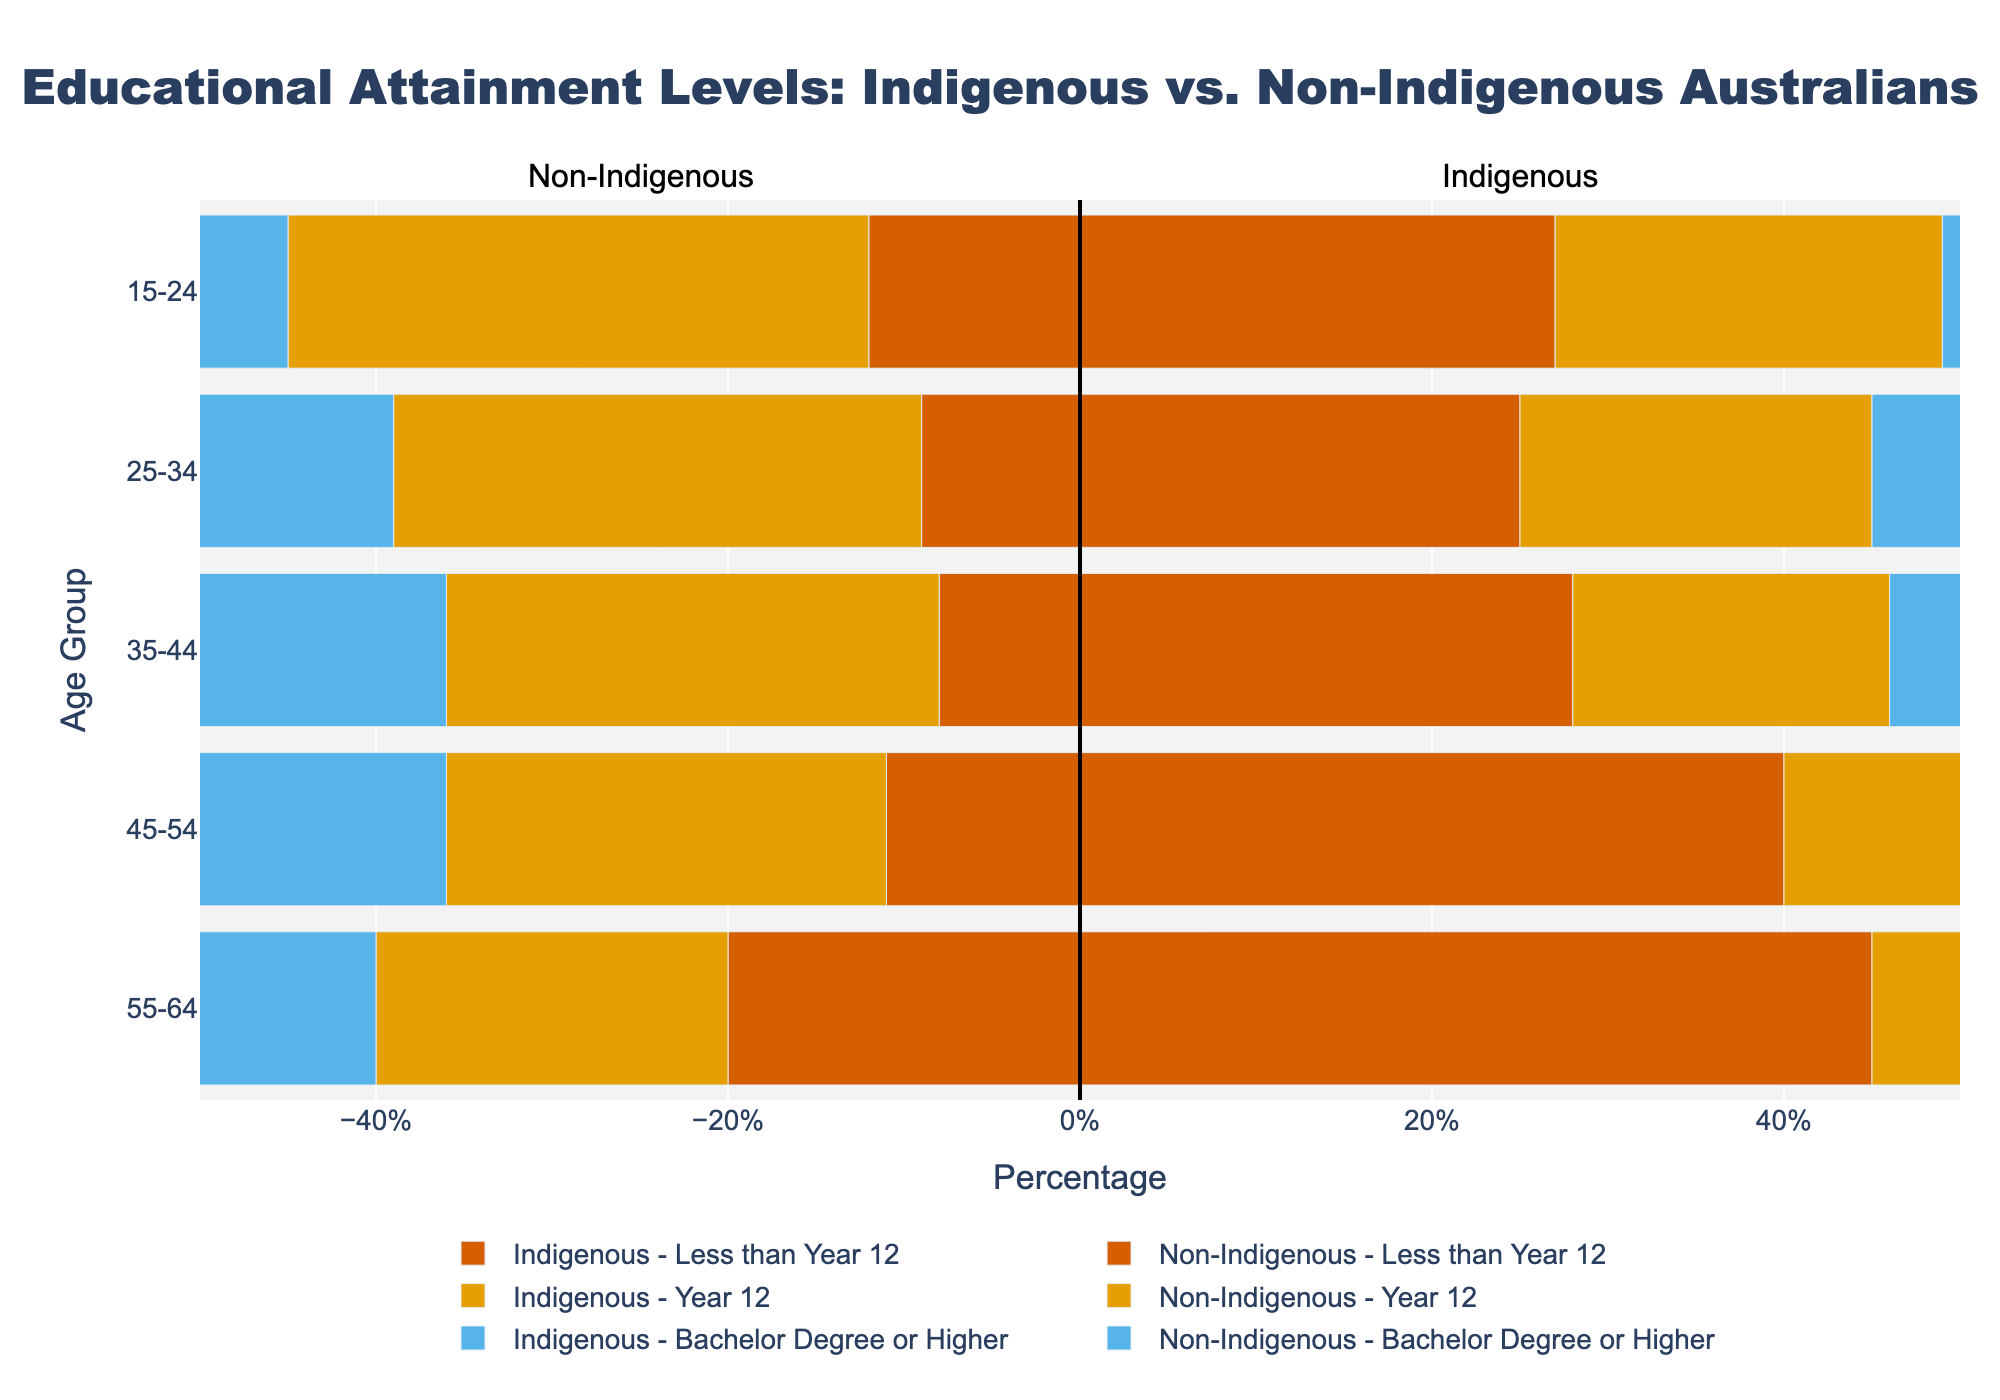Which age group has the highest proportion of Indigenous Australians with a Bachelor's degree or higher? Look at the bar sections for "Bachelor Degree or Higher" across the age groups for Indigenous Australians, and compare heights.
Answer: 25-34 How does the percentage of non-Indigenous Australians with less than Year 12 education in the 15-24 age group compare to Indigenous Australians of the same age group? Compare the lengths of both groups’ bars for "Less than Year 12" within the 15-24 age group. The bar for non-Indigenous is smaller than for Indigenous.
Answer: Non-Indigenous is 15% lower For the 35-44 age group, what is the total percentage of Indigenous Australians who completed at least Year 12? Add both "Year 12" and "Bachelor Degree or Higher" percentages for Indigenous Australians in the 35-44 age group: 18% + 5%.
Answer: 23% What is the difference in the percentage of 55-64-year-old Indigenous Australians with less than Year 12 education compared to non-Indigenous Australians of the same age group? Subtract the non-Indigenous percentage from the Indigenous percentage for "Less than Year 12" in the 55-64 age group: 45% - 20%.
Answer: 25% Which group has a higher percentage of females with a Bachelor’s degree or higher in the 25-34 age group, Indigenous or non-Indigenous? Compare the lengths of the female segments within the "Bachelor Degree or Higher" category for both groups in the 25-34 age group.
Answer: Non-Indigenous For the 45-54 age group, what is the combined percentage of Indigenous males and females with less than Year 12 education? Add the percentages of males and females for "Less than Year 12" in the 45-54 Indigenous age group: 20% (male) + 20% (female).
Answer: 40% How do the proportions of Indigenous Australians with Year 12 education in the 45-54 age group compare to those in the 35-44 age group? Compare the bar lengths for "Year 12" between the two age groups among Indigenous Australians.
Answer: 35-44 is 3% higher What is the percentage difference between Indigenous and non-Indigenous males with a Bachelor’s degree or higher in the 25-34 age group? Subtract the Indigenous percentage from the non-Indigenous percentage for males: 14% - 4%.
Answer: 10% In which age group do non-Indigenous Australians have the highest percentage of individuals with a Bachelor's degree or higher? Look for the longest bar segment for "Bachelor Degree or Higher" within the non-Indigenous data across all age groups.
Answer: 25-34 How do the combined percentages of Indigenous males and females with Year 12 education in the 15-24 age group compare to the non-Indigenous same age group? Add male and female percentages of "Year 12" for both groups and compare: Indigenous (11% + 11%) = 22%, Non-Indigenous (17% + 16%) = 33%.
Answer: Non-Indigenous is 11% higher 